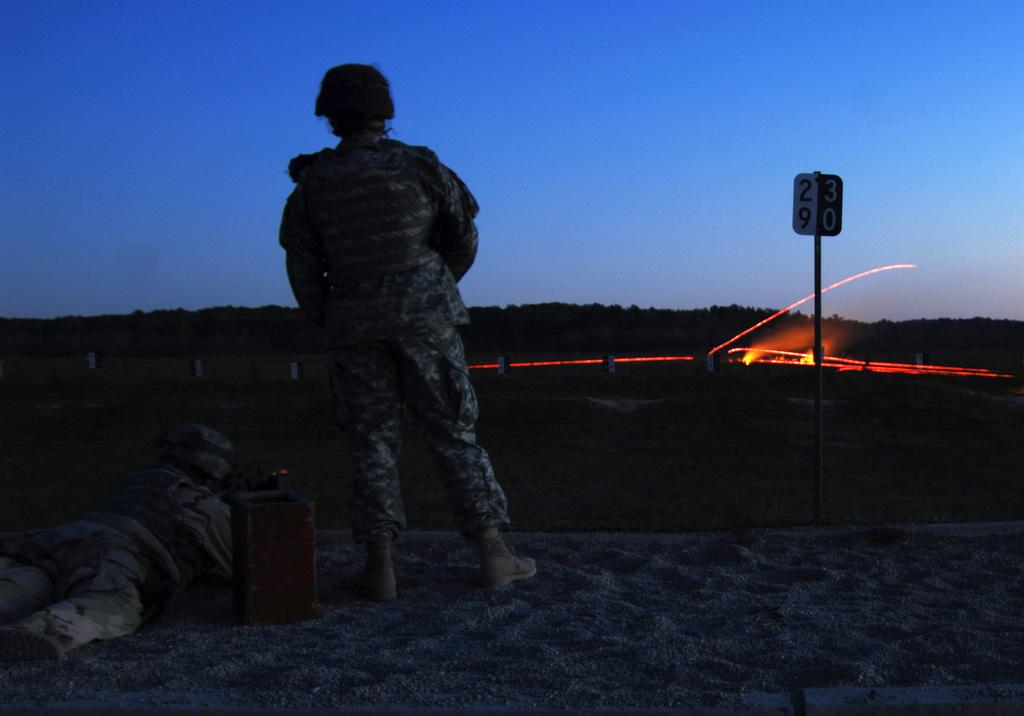What is the main subject of the image? The main subject of the image is a soldier. Can you describe the soldier's position in the image? There is a soldier standing and another soldier lying on a bed in the image. What is present on the right side of the image? There is a board on the right side of the image. What can be seen in the sky in the image? The sky is blue and visible at the top of the image. What type of breakfast is being served to the soldier on the bed? There is no breakfast present in the image; it only features soldiers in different positions and a board on the right side. 